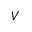Convert formula to latex. <formula><loc_0><loc_0><loc_500><loc_500>V</formula> 